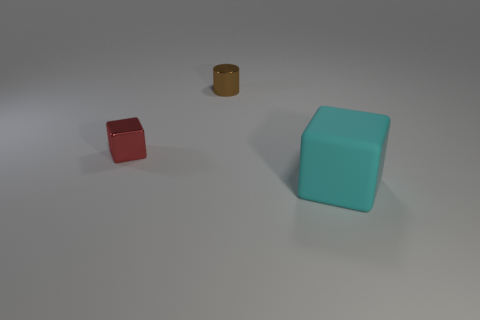What number of big objects are cyan things or red things?
Your answer should be very brief. 1. Are there the same number of shiny things that are to the right of the brown thing and red spheres?
Ensure brevity in your answer.  Yes. Is there a cube in front of the cube on the left side of the matte block?
Provide a succinct answer. Yes. What is the color of the large matte block?
Your answer should be compact. Cyan. There is a object that is both left of the cyan rubber cube and right of the small red thing; how big is it?
Make the answer very short. Small. How many objects are tiny objects to the left of the tiny cylinder or metallic blocks?
Your answer should be very brief. 1. What shape is the thing that is the same material as the tiny cylinder?
Your answer should be very brief. Cube. The tiny brown object has what shape?
Your answer should be compact. Cylinder. What is the color of the thing that is both to the right of the red metallic cube and in front of the small cylinder?
Offer a terse response. Cyan. There is another shiny object that is the same size as the red metal thing; what is its shape?
Provide a succinct answer. Cylinder. 